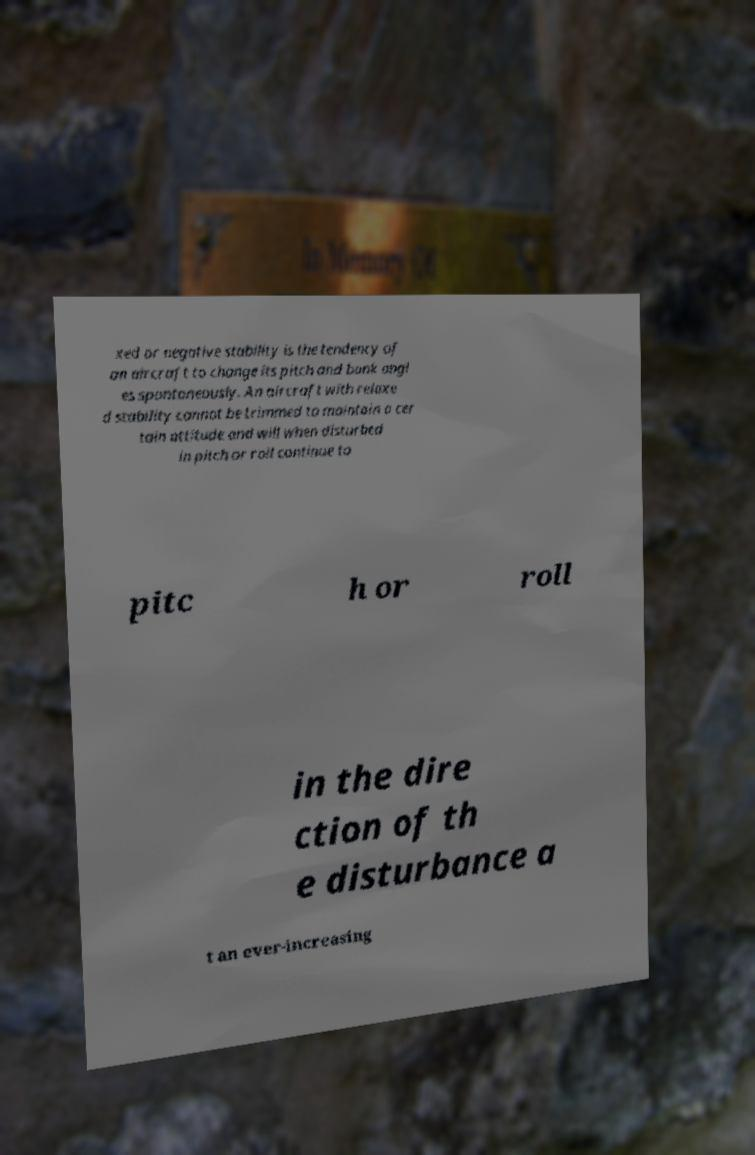For documentation purposes, I need the text within this image transcribed. Could you provide that? xed or negative stability is the tendency of an aircraft to change its pitch and bank angl es spontaneously. An aircraft with relaxe d stability cannot be trimmed to maintain a cer tain attitude and will when disturbed in pitch or roll continue to pitc h or roll in the dire ction of th e disturbance a t an ever-increasing 